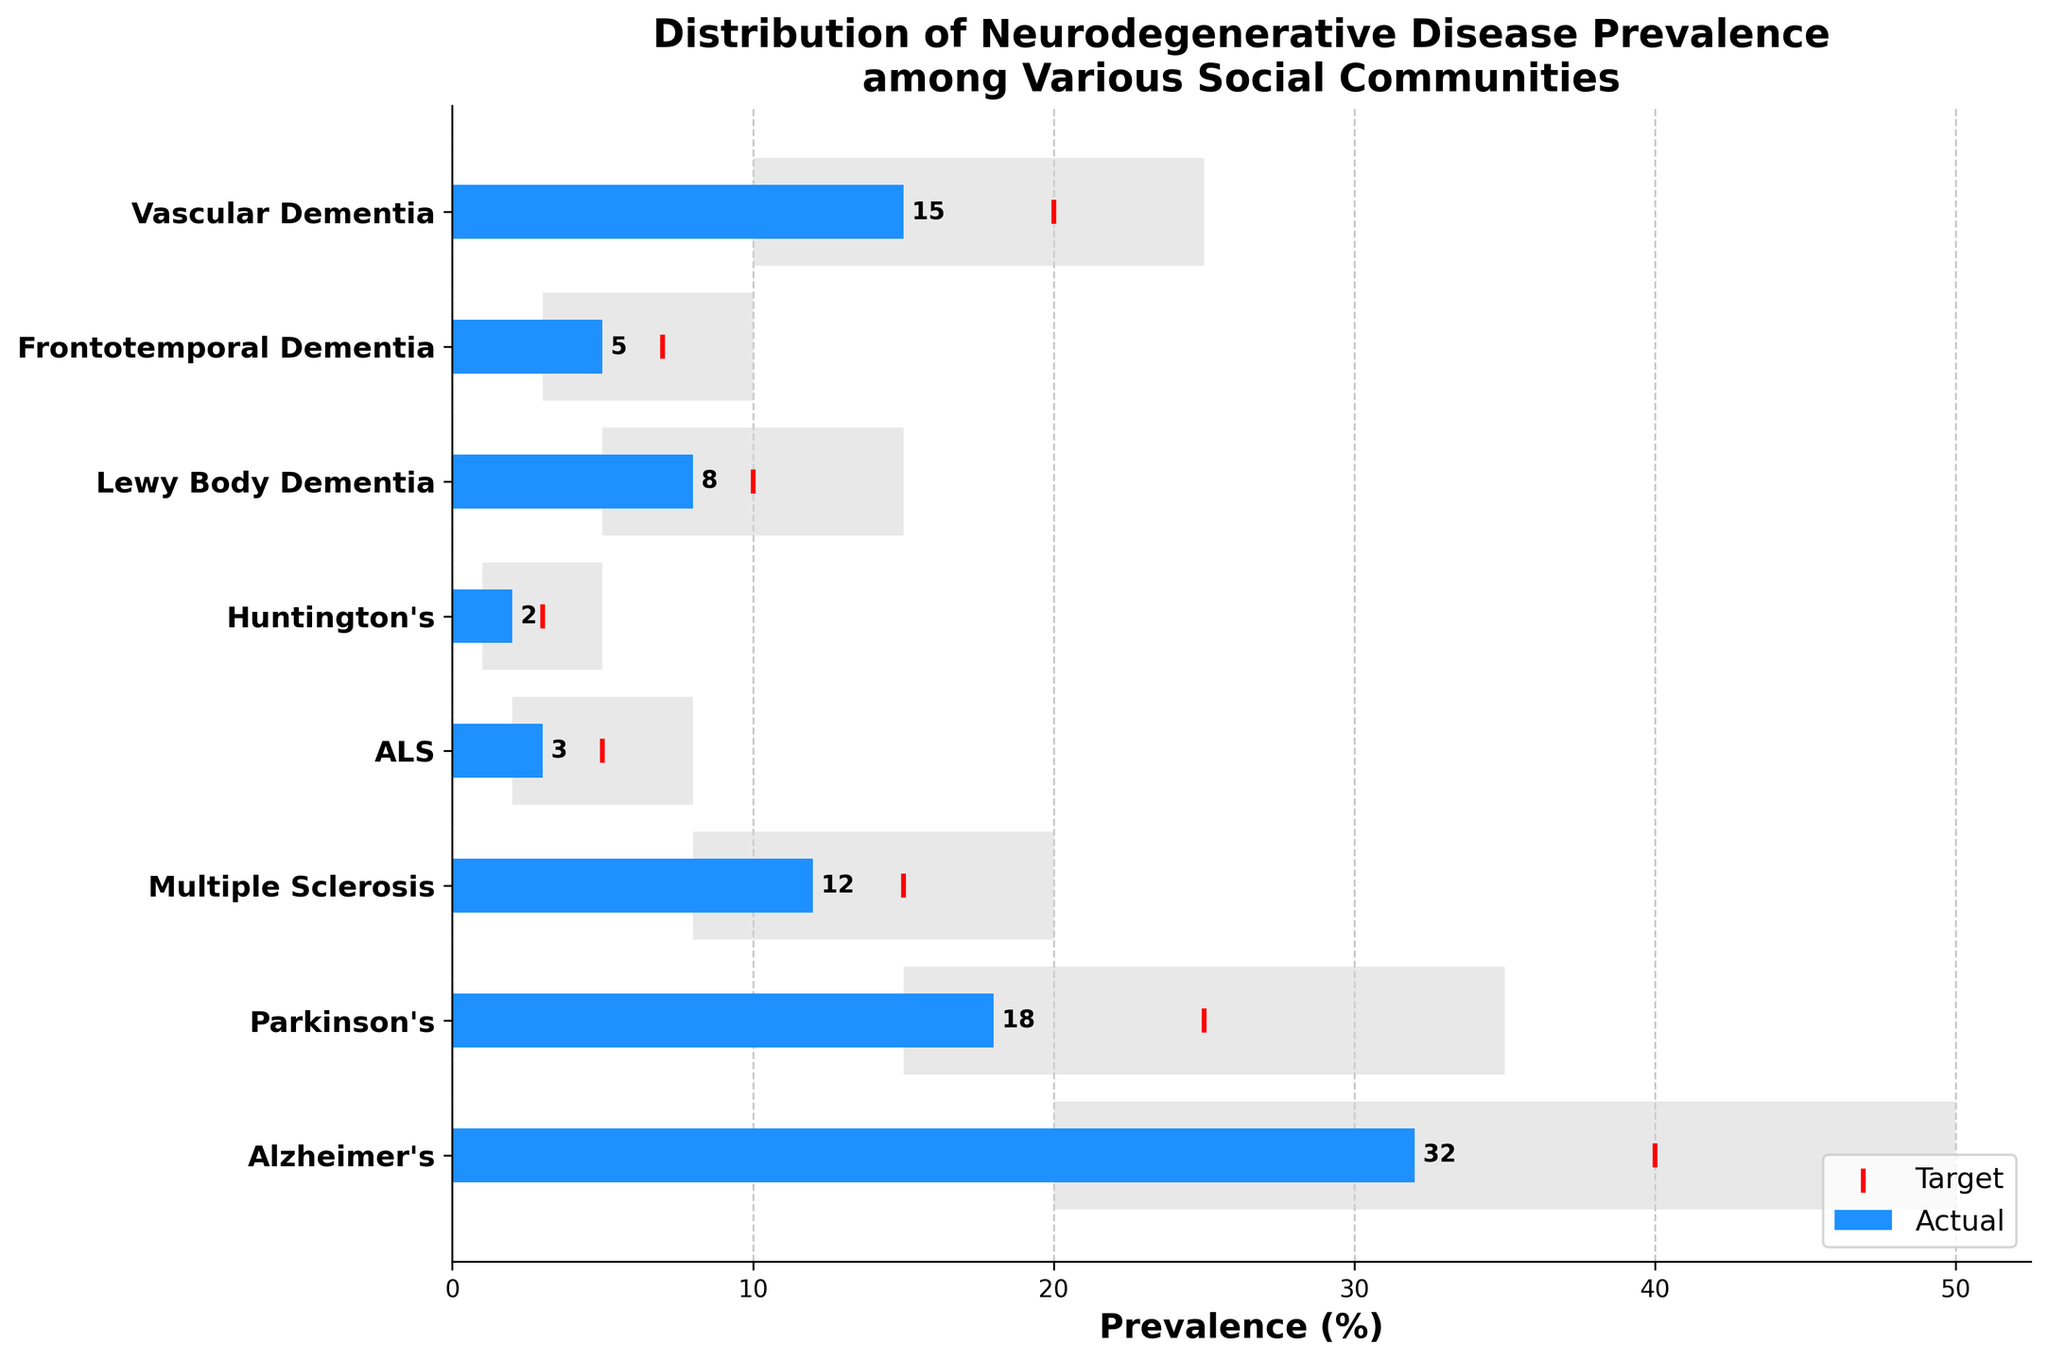What's the title of the figure? The title is prominently displayed at the top of the figure. It reads: "Distribution of Neurodegenerative Disease Prevalence among Various Social Communities."
Answer: Distribution of Neurodegenerative Disease Prevalence among Various Social Communities What color represents the actual prevalence values in the chart? The actual prevalence values are represented by blue-colored horizontal bars.
Answer: Blue How many diseases are displayed in the figure? Counting the number of bars (representing diseases) on the y-axis, there are 8 diseases shown in the figure.
Answer: 8 Which disease has the highest actual prevalence? The highest actual prevalence can be found by identifying the longest blue bar on the chart, which corresponds to Alzheimer's with an actual prevalence of 32.
Answer: Alzheimer's What is the target prevalence value for Multiple Sclerosis? The target prevalence values are shown as red markers. The red marker for Multiple Sclerosis is positioned at 15.
Answer: 15 Which disease shows the largest difference between its actual and target prevalence values? By subtracting the actual values from the target values, Alzheimer's has the largest difference: 40 (target) - 32 (actual) = 8.
Answer: Alzheimer's Are there any diseases where the actual prevalence exceeds the target prevalence? Comparing the blue bar lengths (actual values) to the positions of the red markers (target values), none of the actual prevalences exceed their respective targets.
Answer: No Which disease has the smallest included range (difference between range start and range end)? Subtracting the range start from the range end for each disease, Huntington's has the smallest range of 4 (5-1=4).
Answer: Huntington's For which diseases is the actual prevalence value exactly at the midpoint of the included range? The midpoints of the included ranges (average of range start and range end) need to be calculated: Alzheimer's (35), Parkinson's (25), Multiple Sclerosis (14), ALS (5), Huntington's (3), Lewy Body Dementia (10), Frontotemporal Dementia (6.5), Vascular Dementia (17.5). Comparing these midpoints with the actual values reveals that none of the actual prevalences exactly match the midpoints.
Answer: None What's the total cumulative target prevalence for all diseases combined? Adding the target values for all diseases: 40 (Alzheimer's) + 25 (Parkinson's) + 15 (Multiple Sclerosis) + 5 (ALS) + 3 (Huntington's) + 10 (Lewy Body Dementia) + 7 (Frontotemporal Dementia) + 20 (Vascular Dementia) = 125.
Answer: 125 